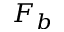Convert formula to latex. <formula><loc_0><loc_0><loc_500><loc_500>F _ { b }</formula> 